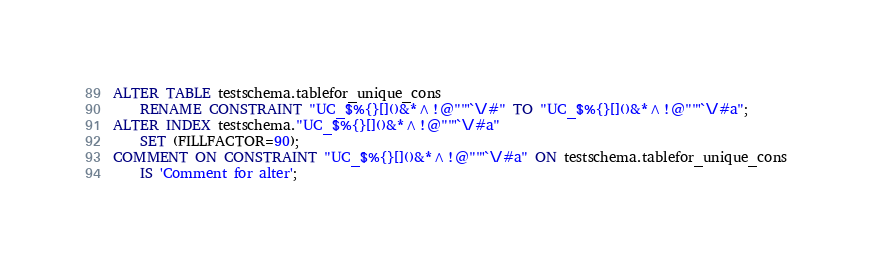<code> <loc_0><loc_0><loc_500><loc_500><_SQL_>ALTER TABLE testschema.tablefor_unique_cons
    RENAME CONSTRAINT "UC_$%{}[]()&*^!@""'`\/#" TO "UC_$%{}[]()&*^!@""'`\/#a";
ALTER INDEX testschema."UC_$%{}[]()&*^!@""'`\/#a"
    SET (FILLFACTOR=90);
COMMENT ON CONSTRAINT "UC_$%{}[]()&*^!@""'`\/#a" ON testschema.tablefor_unique_cons
    IS 'Comment for alter';
</code> 